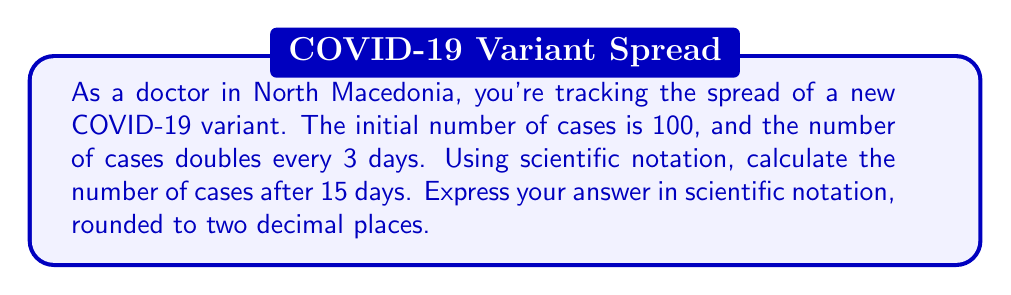Help me with this question. Let's approach this step-by-step:

1) First, we need to determine how many times the number of cases doubles in 15 days:
   $\frac{15 \text{ days}}{3 \text{ days per doubling}} = 5 \text{ doublings}$

2) We can express this as an exponential growth equation:
   $\text{Final cases} = \text{Initial cases} \times 2^{\text{number of doublings}}$

3) Plugging in our values:
   $\text{Final cases} = 100 \times 2^5$

4) Let's calculate $2^5$:
   $2^5 = 2 \times 2 \times 2 \times 2 \times 2 = 32$

5) Now our equation is:
   $\text{Final cases} = 100 \times 32 = 3,200$

6) To express this in scientific notation, we move the decimal point to the left until we have a number between 1 and 10, and then count how many places we moved:
   $3,200 = 3.2 \times 10^3$

Therefore, after 15 days, the number of cases in scientific notation is $3.2 \times 10^3$.
Answer: $3.2 \times 10^3$ 